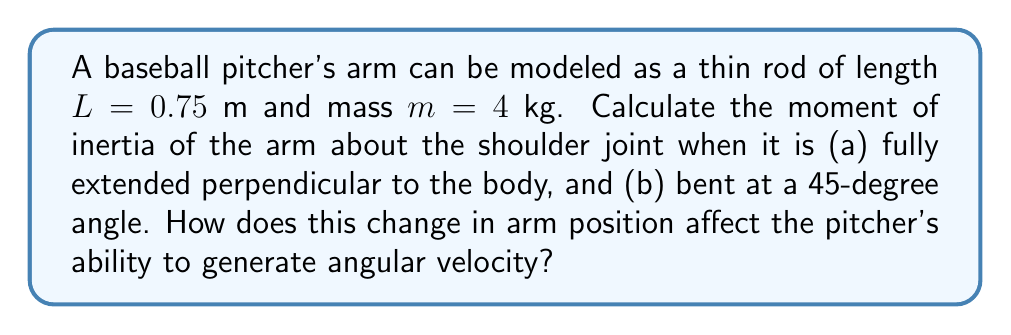Help me with this question. Let's approach this step-by-step:

1) The moment of inertia for a thin rod about one end is given by:

   $$I = \frac{1}{3}mL^2$$

2) For case (a), when the arm is fully extended:
   
   $$I_a = \frac{1}{3} \cdot 4 \text{ kg} \cdot (0.75 \text{ m})^2 = 0.75 \text{ kg·m}^2$$

3) For case (b), when the arm is bent at a 45-degree angle:
   
   The effective length is now $L \cdot \cos(45°)$:
   
   $$I_b = \frac{1}{3} \cdot 4 \text{ kg} \cdot (0.75 \text{ m} \cdot \cos(45°))^2$$
   $$I_b = \frac{1}{3} \cdot 4 \text{ kg} \cdot (0.75 \text{ m} \cdot \frac{\sqrt{2}}{2})^2 \approx 0.375 \text{ kg·m}^2$$

4) The ratio of moments of inertia:
   
   $$\frac{I_b}{I_a} = \frac{0.375}{0.75} = 0.5$$

5) Effect on angular velocity:
   The angular momentum $L = I\omega$ is conserved during the pitching motion. As $I$ decreases, $\omega$ must increase proportionally. The bent arm position (b) has half the moment of inertia of the extended position (a), so it can achieve twice the angular velocity for the same angular momentum.

This allows the pitcher to generate higher angular velocity in the bent arm position, which can be translated into higher linear velocity of the ball upon release.
Answer: $I_a = 0.75 \text{ kg·m}^2$, $I_b \approx 0.375 \text{ kg·m}^2$. Bent arm allows ~2x angular velocity. 